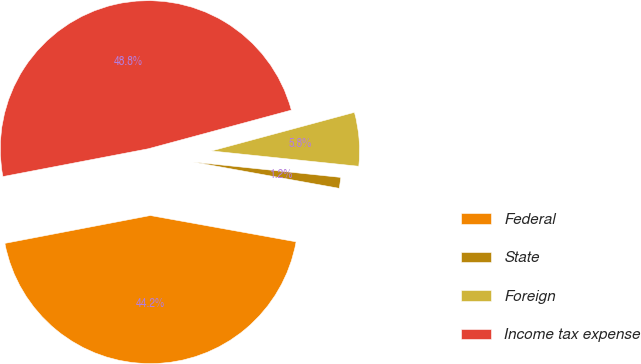Convert chart to OTSL. <chart><loc_0><loc_0><loc_500><loc_500><pie_chart><fcel>Federal<fcel>State<fcel>Foreign<fcel>Income tax expense<nl><fcel>44.15%<fcel>1.19%<fcel>5.85%<fcel>48.81%<nl></chart> 